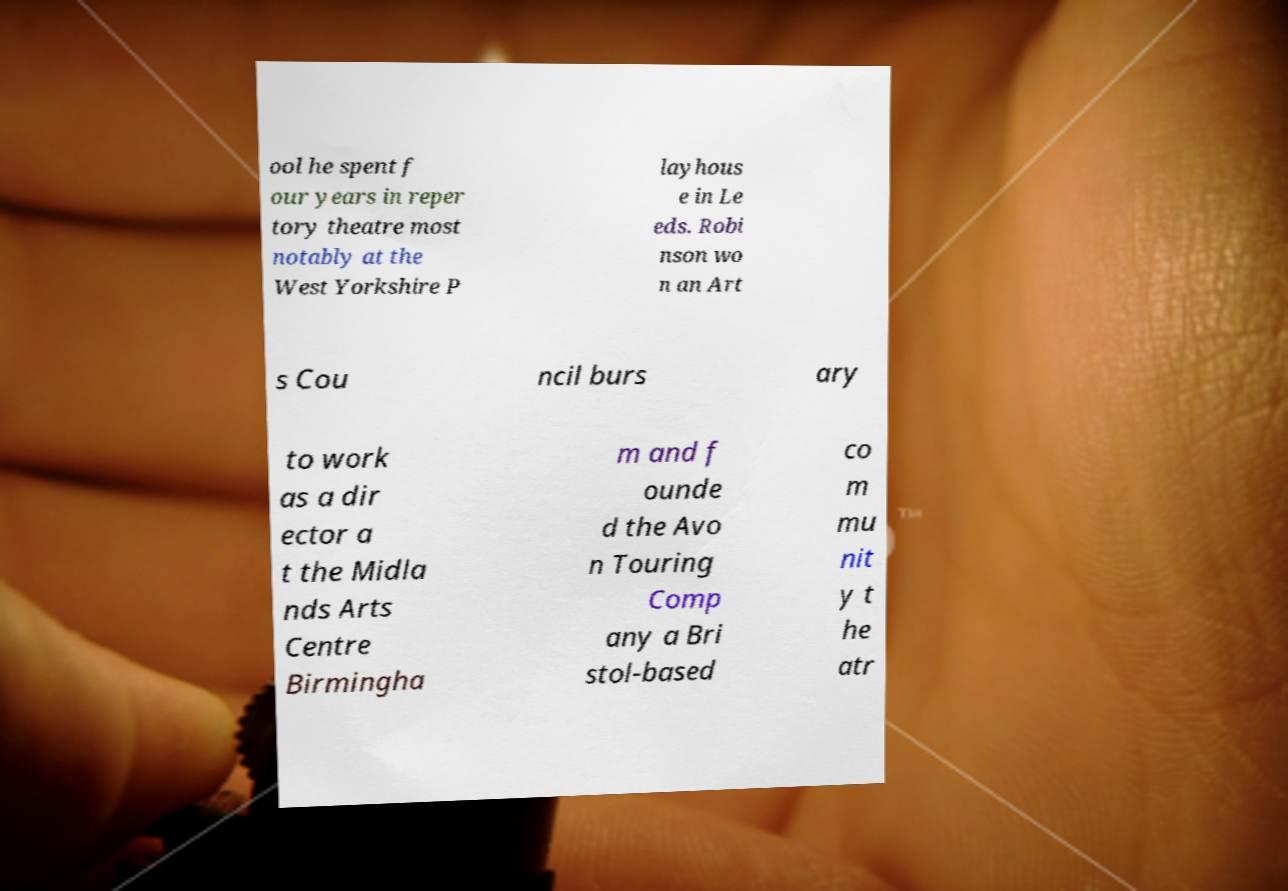I need the written content from this picture converted into text. Can you do that? ool he spent f our years in reper tory theatre most notably at the West Yorkshire P layhous e in Le eds. Robi nson wo n an Art s Cou ncil burs ary to work as a dir ector a t the Midla nds Arts Centre Birmingha m and f ounde d the Avo n Touring Comp any a Bri stol-based co m mu nit y t he atr 